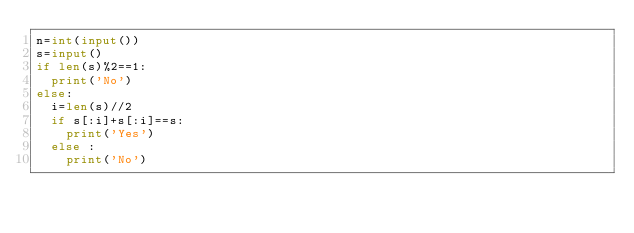<code> <loc_0><loc_0><loc_500><loc_500><_Python_>n=int(input())
s=input()
if len(s)%2==1:
  print('No')
else:
  i=len(s)//2
  if s[:i]+s[:i]==s:
    print('Yes')
  else :
    print('No')</code> 